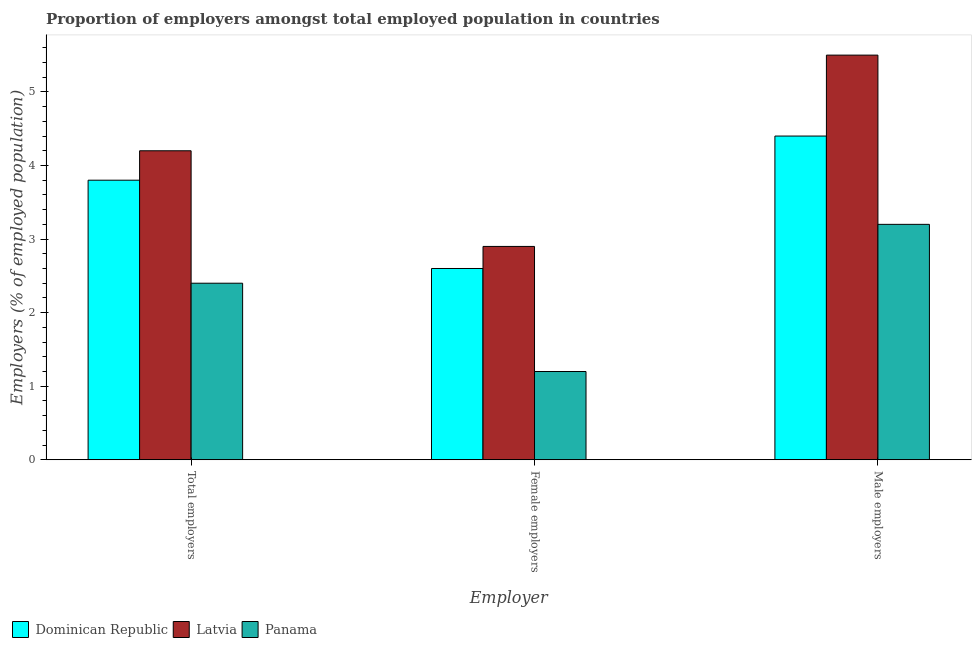Are the number of bars per tick equal to the number of legend labels?
Offer a very short reply. Yes. How many bars are there on the 3rd tick from the right?
Offer a terse response. 3. What is the label of the 2nd group of bars from the left?
Offer a very short reply. Female employers. What is the percentage of total employers in Panama?
Make the answer very short. 2.4. Across all countries, what is the maximum percentage of female employers?
Your answer should be very brief. 2.9. Across all countries, what is the minimum percentage of total employers?
Offer a very short reply. 2.4. In which country was the percentage of male employers maximum?
Provide a short and direct response. Latvia. In which country was the percentage of male employers minimum?
Provide a succinct answer. Panama. What is the total percentage of total employers in the graph?
Make the answer very short. 10.4. What is the difference between the percentage of male employers in Panama and that in Latvia?
Keep it short and to the point. -2.3. What is the average percentage of total employers per country?
Your answer should be compact. 3.47. What is the difference between the percentage of total employers and percentage of male employers in Latvia?
Provide a short and direct response. -1.3. What is the ratio of the percentage of male employers in Latvia to that in Dominican Republic?
Your response must be concise. 1.25. Is the percentage of total employers in Latvia less than that in Dominican Republic?
Make the answer very short. No. What is the difference between the highest and the second highest percentage of total employers?
Keep it short and to the point. 0.4. What is the difference between the highest and the lowest percentage of female employers?
Your answer should be compact. 1.7. In how many countries, is the percentage of male employers greater than the average percentage of male employers taken over all countries?
Give a very brief answer. 2. What does the 1st bar from the left in Total employers represents?
Provide a succinct answer. Dominican Republic. What does the 1st bar from the right in Female employers represents?
Your answer should be compact. Panama. How many countries are there in the graph?
Offer a very short reply. 3. Are the values on the major ticks of Y-axis written in scientific E-notation?
Provide a short and direct response. No. Does the graph contain grids?
Your answer should be compact. No. Where does the legend appear in the graph?
Give a very brief answer. Bottom left. How many legend labels are there?
Provide a succinct answer. 3. What is the title of the graph?
Your response must be concise. Proportion of employers amongst total employed population in countries. What is the label or title of the X-axis?
Your answer should be very brief. Employer. What is the label or title of the Y-axis?
Provide a short and direct response. Employers (% of employed population). What is the Employers (% of employed population) of Dominican Republic in Total employers?
Offer a very short reply. 3.8. What is the Employers (% of employed population) in Latvia in Total employers?
Offer a very short reply. 4.2. What is the Employers (% of employed population) of Panama in Total employers?
Ensure brevity in your answer.  2.4. What is the Employers (% of employed population) in Dominican Republic in Female employers?
Keep it short and to the point. 2.6. What is the Employers (% of employed population) of Latvia in Female employers?
Give a very brief answer. 2.9. What is the Employers (% of employed population) in Panama in Female employers?
Keep it short and to the point. 1.2. What is the Employers (% of employed population) in Dominican Republic in Male employers?
Provide a succinct answer. 4.4. What is the Employers (% of employed population) of Panama in Male employers?
Give a very brief answer. 3.2. Across all Employer, what is the maximum Employers (% of employed population) of Dominican Republic?
Make the answer very short. 4.4. Across all Employer, what is the maximum Employers (% of employed population) in Panama?
Your answer should be compact. 3.2. Across all Employer, what is the minimum Employers (% of employed population) in Dominican Republic?
Keep it short and to the point. 2.6. Across all Employer, what is the minimum Employers (% of employed population) in Latvia?
Give a very brief answer. 2.9. Across all Employer, what is the minimum Employers (% of employed population) in Panama?
Offer a very short reply. 1.2. What is the total Employers (% of employed population) of Dominican Republic in the graph?
Your response must be concise. 10.8. What is the total Employers (% of employed population) of Panama in the graph?
Your answer should be very brief. 6.8. What is the difference between the Employers (% of employed population) in Panama in Total employers and that in Female employers?
Keep it short and to the point. 1.2. What is the difference between the Employers (% of employed population) of Dominican Republic in Total employers and that in Male employers?
Offer a very short reply. -0.6. What is the difference between the Employers (% of employed population) of Latvia in Total employers and that in Male employers?
Your response must be concise. -1.3. What is the difference between the Employers (% of employed population) in Dominican Republic in Female employers and that in Male employers?
Provide a succinct answer. -1.8. What is the difference between the Employers (% of employed population) of Dominican Republic in Total employers and the Employers (% of employed population) of Latvia in Female employers?
Give a very brief answer. 0.9. What is the difference between the Employers (% of employed population) of Dominican Republic in Total employers and the Employers (% of employed population) of Latvia in Male employers?
Keep it short and to the point. -1.7. What is the difference between the Employers (% of employed population) in Dominican Republic in Total employers and the Employers (% of employed population) in Panama in Male employers?
Offer a very short reply. 0.6. What is the difference between the Employers (% of employed population) in Latvia in Total employers and the Employers (% of employed population) in Panama in Male employers?
Give a very brief answer. 1. What is the difference between the Employers (% of employed population) of Dominican Republic in Female employers and the Employers (% of employed population) of Panama in Male employers?
Ensure brevity in your answer.  -0.6. What is the difference between the Employers (% of employed population) of Latvia in Female employers and the Employers (% of employed population) of Panama in Male employers?
Your answer should be compact. -0.3. What is the average Employers (% of employed population) of Dominican Republic per Employer?
Give a very brief answer. 3.6. What is the average Employers (% of employed population) in Latvia per Employer?
Ensure brevity in your answer.  4.2. What is the average Employers (% of employed population) of Panama per Employer?
Your answer should be compact. 2.27. What is the difference between the Employers (% of employed population) of Dominican Republic and Employers (% of employed population) of Latvia in Total employers?
Your response must be concise. -0.4. What is the difference between the Employers (% of employed population) of Dominican Republic and Employers (% of employed population) of Panama in Female employers?
Give a very brief answer. 1.4. What is the difference between the Employers (% of employed population) of Latvia and Employers (% of employed population) of Panama in Female employers?
Offer a very short reply. 1.7. What is the difference between the Employers (% of employed population) of Dominican Republic and Employers (% of employed population) of Panama in Male employers?
Offer a terse response. 1.2. What is the ratio of the Employers (% of employed population) in Dominican Republic in Total employers to that in Female employers?
Provide a succinct answer. 1.46. What is the ratio of the Employers (% of employed population) of Latvia in Total employers to that in Female employers?
Make the answer very short. 1.45. What is the ratio of the Employers (% of employed population) of Panama in Total employers to that in Female employers?
Offer a very short reply. 2. What is the ratio of the Employers (% of employed population) of Dominican Republic in Total employers to that in Male employers?
Offer a terse response. 0.86. What is the ratio of the Employers (% of employed population) of Latvia in Total employers to that in Male employers?
Your response must be concise. 0.76. What is the ratio of the Employers (% of employed population) of Panama in Total employers to that in Male employers?
Provide a short and direct response. 0.75. What is the ratio of the Employers (% of employed population) of Dominican Republic in Female employers to that in Male employers?
Give a very brief answer. 0.59. What is the ratio of the Employers (% of employed population) of Latvia in Female employers to that in Male employers?
Your answer should be very brief. 0.53. What is the ratio of the Employers (% of employed population) of Panama in Female employers to that in Male employers?
Offer a very short reply. 0.38. What is the difference between the highest and the second highest Employers (% of employed population) in Dominican Republic?
Make the answer very short. 0.6. What is the difference between the highest and the second highest Employers (% of employed population) in Panama?
Provide a succinct answer. 0.8. What is the difference between the highest and the lowest Employers (% of employed population) in Dominican Republic?
Your response must be concise. 1.8. What is the difference between the highest and the lowest Employers (% of employed population) in Panama?
Your answer should be compact. 2. 